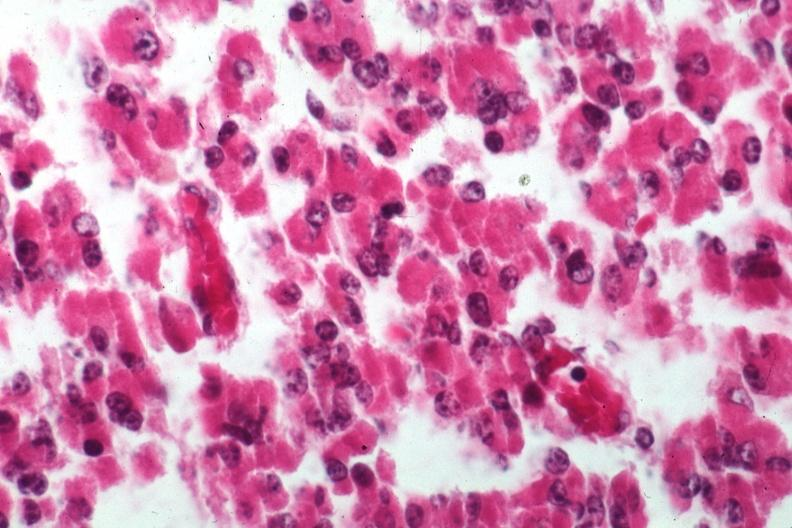where is this part in the figure?
Answer the question using a single word or phrase. Endocrine system 